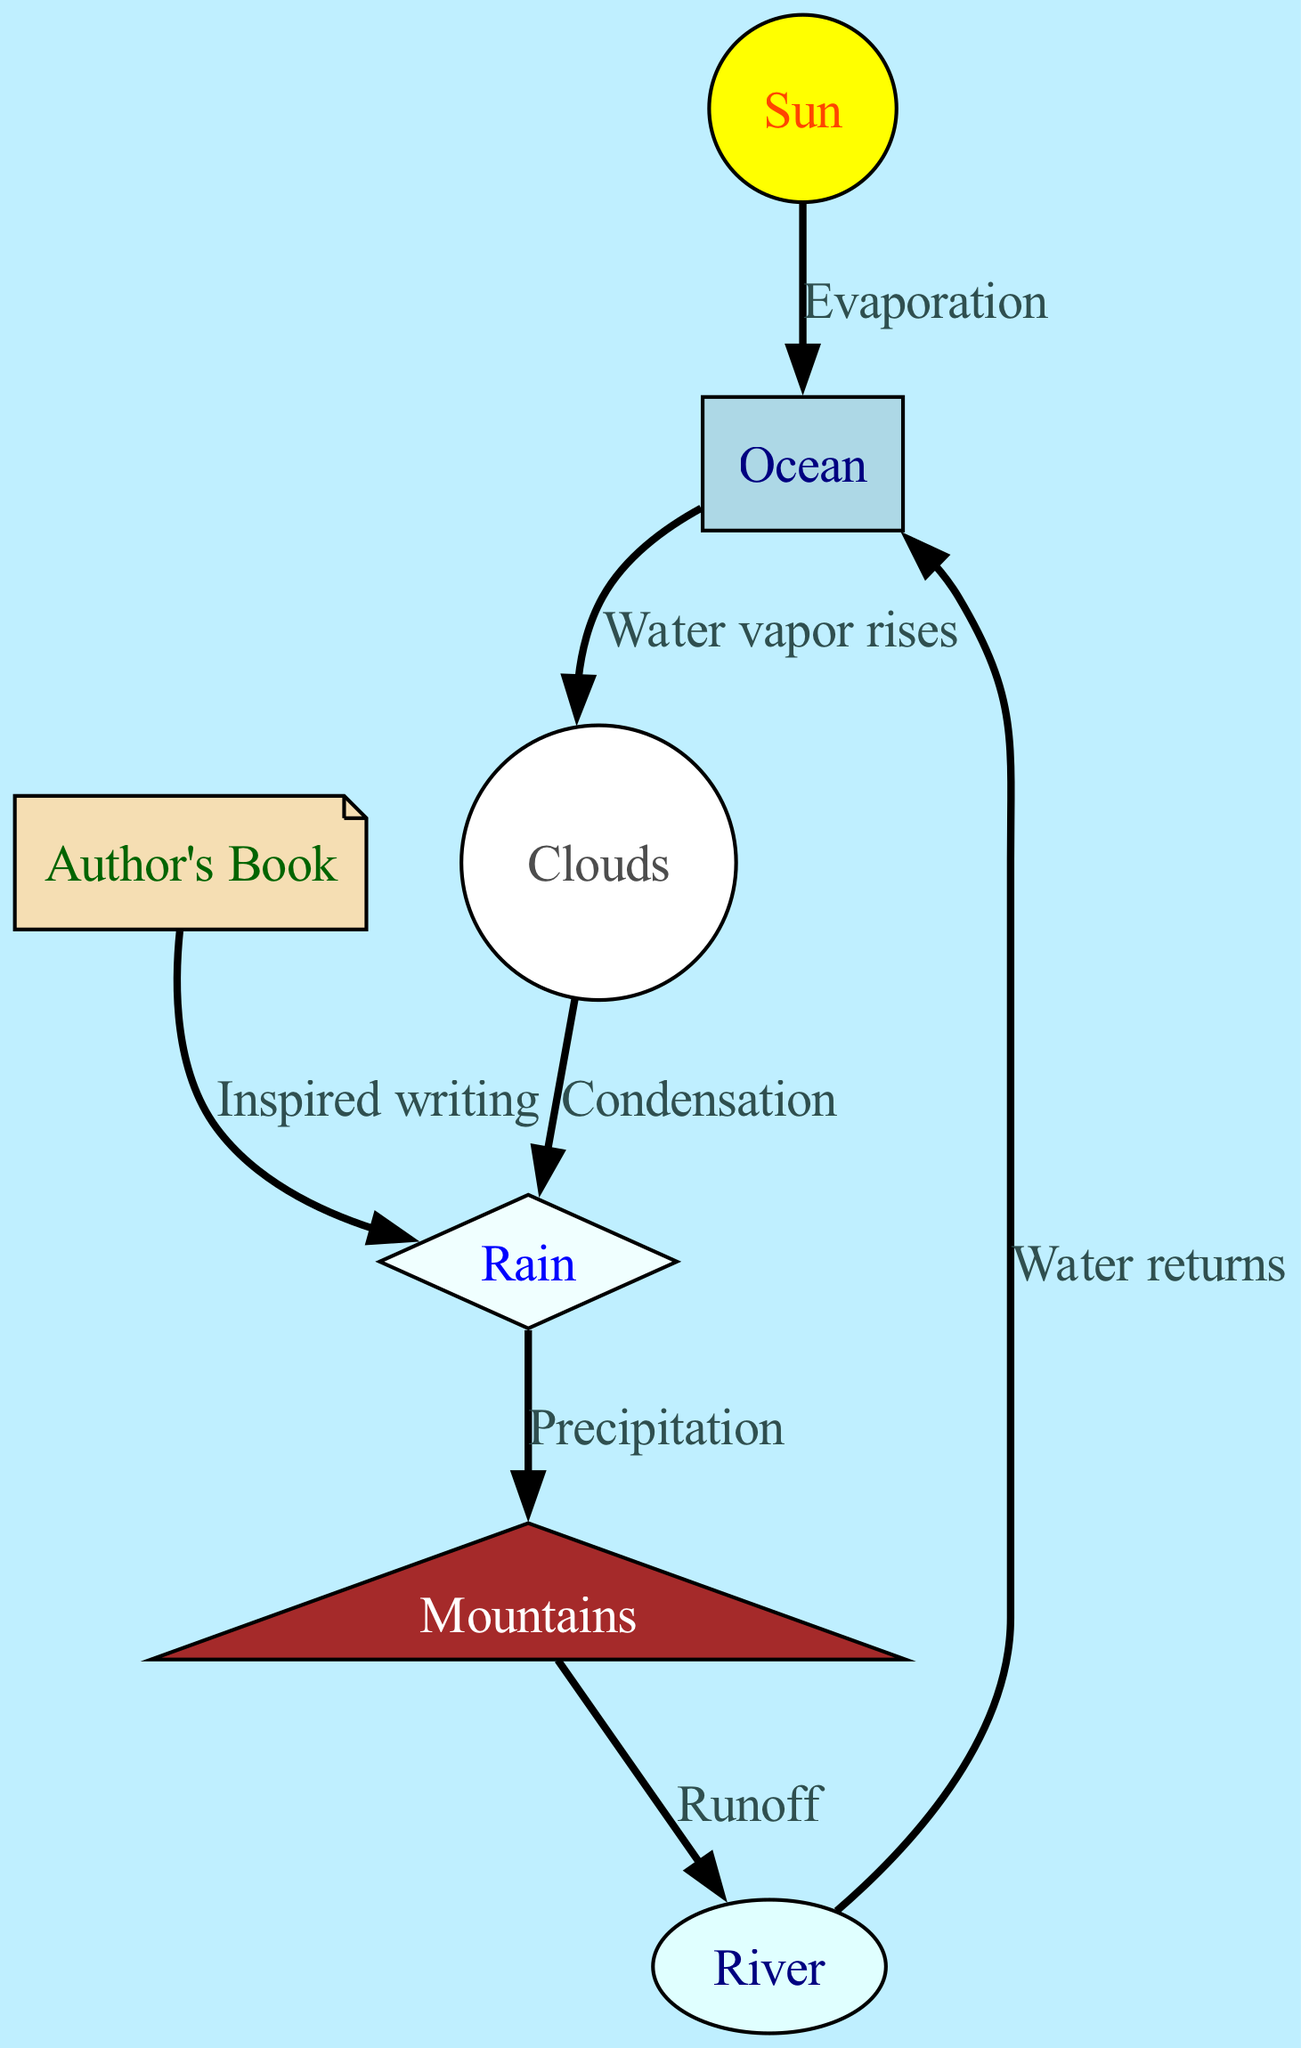What is the starting point of the water cycle in the diagram? The diagram indicates that the water cycle starts with the "Ocean," which is depicted as a node at the base of the diagram.
Answer: Ocean What process occurs between the Sun and the Ocean? The diagram shows an edge labeled "Evaporation" connecting the Sun to the Ocean, indicating this process occurs when the Sun heats the water.
Answer: Evaporation Which node represents the first form of water after evaporation? Following the evaporation process represented by the edge from the Ocean, the next node is "Clouds," which signifies the formation of water vapor.
Answer: Clouds How many nodes are depicted in the diagram? The diagram contains seven specific nodes representing different components of the water cycle, each connected by edges representing processes.
Answer: 7 What process takes place between Clouds and Rain? The edge between the Clouds and Rain nodes is labeled "Condensation," which describes the process where vapor turns back to liquid.
Answer: Condensation After rain falls, what geographical feature does the water flow towards? The edge from Rain leads to the Mountains node, indicating that precipitation flows towards mountainous areas after it rains.
Answer: Mountains What is the final destination of the water as indicated in the diagram? The diagram shows an edge from the River node back to the Ocean node, indicating that water ultimately returns to the ocean.
Answer: Ocean Which node represents an element influenced by the outcomes of the water cycle? The edge labeled "Inspired writing" connects the Author's Book node to Rain, demonstrating the effect of the water cycle on creative endeavors.
Answer: Author's Book What type of edge connects the Rain to the Mountains? The edge connecting these two nodes is labeled "Precipitation," pointing to the process where rainwater accumulates and flows into the mountains.
Answer: Precipitation 